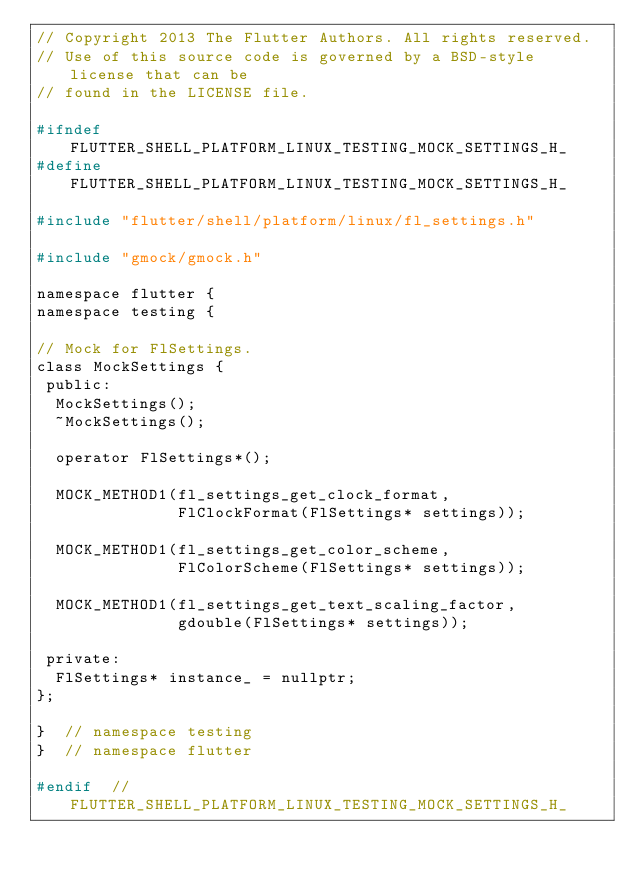Convert code to text. <code><loc_0><loc_0><loc_500><loc_500><_C_>// Copyright 2013 The Flutter Authors. All rights reserved.
// Use of this source code is governed by a BSD-style license that can be
// found in the LICENSE file.

#ifndef FLUTTER_SHELL_PLATFORM_LINUX_TESTING_MOCK_SETTINGS_H_
#define FLUTTER_SHELL_PLATFORM_LINUX_TESTING_MOCK_SETTINGS_H_

#include "flutter/shell/platform/linux/fl_settings.h"

#include "gmock/gmock.h"

namespace flutter {
namespace testing {

// Mock for FlSettings.
class MockSettings {
 public:
  MockSettings();
  ~MockSettings();

  operator FlSettings*();

  MOCK_METHOD1(fl_settings_get_clock_format,
               FlClockFormat(FlSettings* settings));

  MOCK_METHOD1(fl_settings_get_color_scheme,
               FlColorScheme(FlSettings* settings));

  MOCK_METHOD1(fl_settings_get_text_scaling_factor,
               gdouble(FlSettings* settings));

 private:
  FlSettings* instance_ = nullptr;
};

}  // namespace testing
}  // namespace flutter

#endif  // FLUTTER_SHELL_PLATFORM_LINUX_TESTING_MOCK_SETTINGS_H_
</code> 